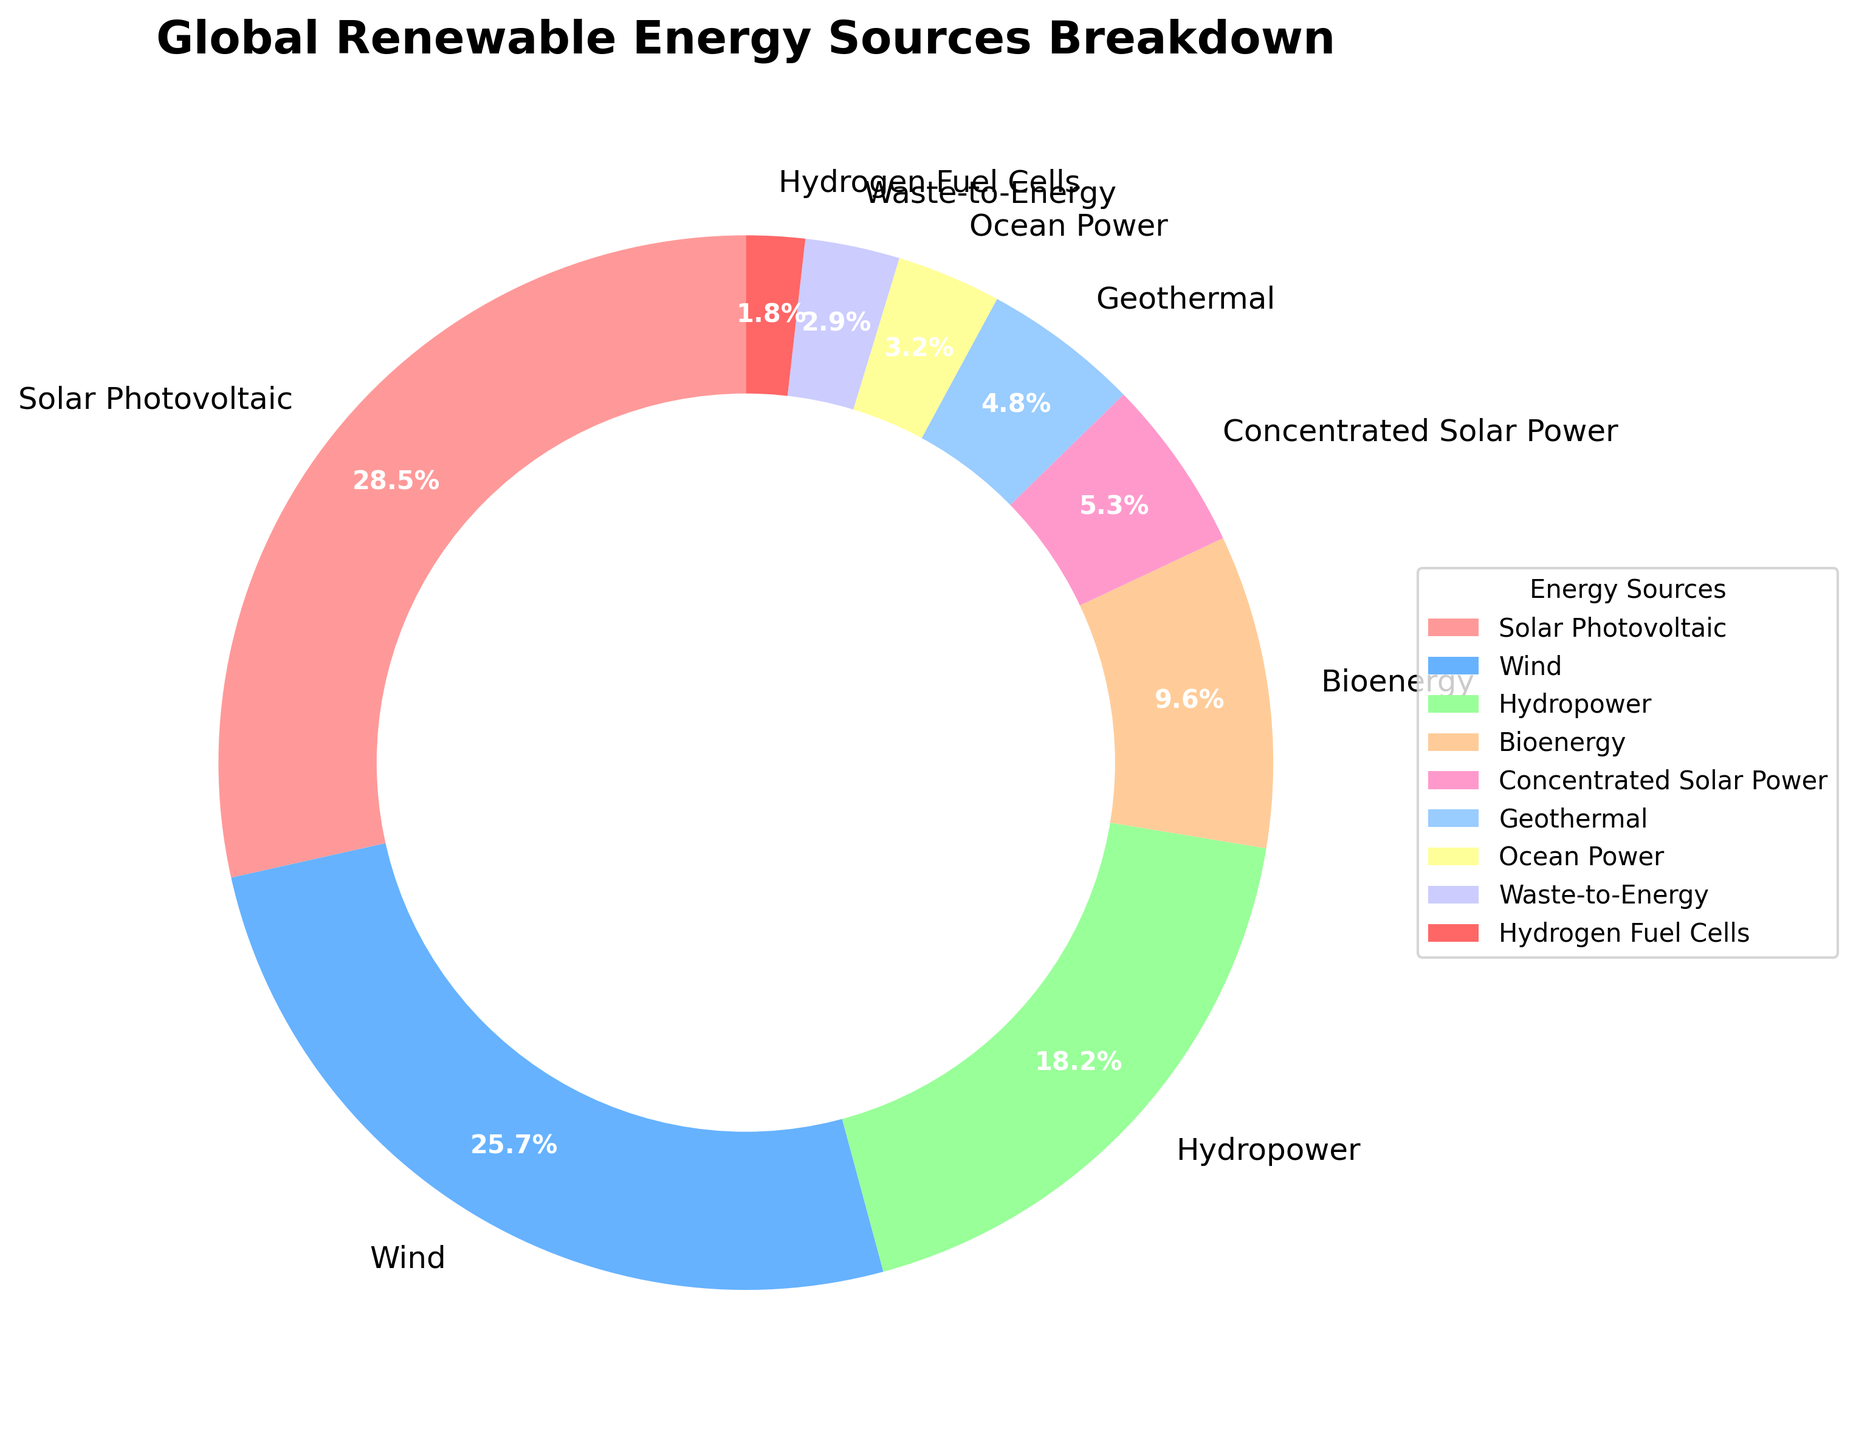Which renewable energy source has the highest percentage? The figure shows the breakdown of global renewable energy sources by type. To determine which source has the highest percentage, identify the segment with the largest value in the pie chart.
Answer: Solar Photovoltaic What is the combined percentage of Wind and Hydropower? Locate the percentages for Wind and Hydropower in the pie chart (25.7% and 18.2%, respectively), then add these two values together.
Answer: 43.9% Which renewable energy source contributes less than 5%? Identify the segments of the pie chart where the percentage is less than 5%. These include Geothermal (4.8%), Ocean Power (3.2%), Waste-to-Energy (2.9%), and Hydrogen Fuel Cells (1.8%).
Answer: Geothermal, Ocean Power, Waste-to-Energy, Hydrogen Fuel Cells What is the difference in percentage between Bioenergy and Concentrated Solar Power? Locate the percentages for Bioenergy and Concentrated Solar Power in the pie chart. Bioenergy is 9.6% and Concentrated Solar Power is 5.3%. Subtract the smaller percentage from the larger percentage: 9.6% - 5.3% = 4.3%.
Answer: 4.3% Which energy source has a percentage closest to 25%? Examine the pie chart and identify the segment whose percentage is closest to 25%. Wind has a percentage of 25.7%, which is closest to 25%.
Answer: Wind How many renewable energy sources contribute more than 20%? Count the segments of the pie chart where the percentage is greater than 20%. There are two such sources: Solar Photovoltaic (28.5%) and Wind (25.7%).
Answer: 2 Is the percentage of Solar Photovoltaic more than double that of Hydropower? Compare the percentage of Solar Photovoltaic (28.5%) with double the percentage of Hydropower (2 * 18.2% = 36.4%). Since 28.5% is less than 36.4%, Solar Photovoltaic is not more than double Hydropower.
Answer: No What is the average percentage of Ocean Power, Waste-to-Energy, and Hydrogen Fuel Cells? Add the percentages for Ocean Power (3.2%), Waste-to-Energy (2.9%), and Hydrogen Fuel Cells (1.8%) and divide by the number of sources: (3.2% + 2.9% + 1.8%) / 3 = 7.9% / 3 = 2.63%.
Answer: 2.63% What is the color of the segment representing Concentrated Solar Power? Look at the color palette used in the pie chart and identify the color corresponding to the segment labeled "Concentrated Solar Power".
Answer: Pink Which energy sources have a similar visual representation due to their close percentages? Compare the sizes of the segments in the pie chart to find those that are visually similar in size due to close percentages. 'Ocean Power' (3.2%) and 'Waste-to-Energy' (2.9%) are close in percentage and, therefore, similar in visual representation.
Answer: Ocean Power, Waste-to-Energy 